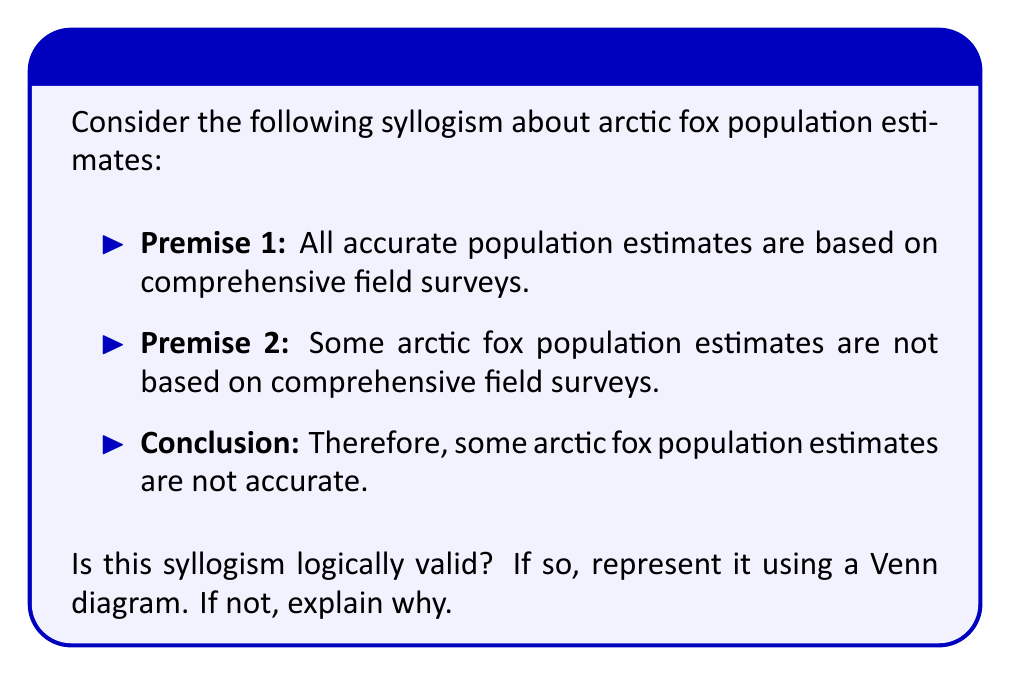Give your solution to this math problem. To determine the logical validity of this syllogism, let's follow these steps:

1. Identify the terms:
   A = accurate population estimates
   B = estimates based on comprehensive field surveys
   C = arctic fox population estimates

2. Translate the premises and conclusion into logical notation:
   Premise 1: All A are B → A ⊆ B
   Premise 2: Some C are not B → C ∩ B' ≠ ∅
   Conclusion: Some C are not A → C ∩ A' ≠ ∅

3. Analyze the logical structure:
   This syllogism follows the form of AOO-2, which is a valid syllogistic form.

4. Represent the syllogism using a Venn diagram:

[asy]
unitsize(1cm);

pair A = (0,0), B = (1,0), C = (0.5,0.866);
real r = 1;

draw(circle(A,r), blue);
draw(circle(B,r), red);
draw(circle(C,r), green);

label("A", A, SW);
label("B", B, SE);
label("C", C, N);

fill((-0.5,-0.866)--(0.5,-0.866)--(0,0)--cycle, blue+opacity(0.2));
fill((1.5,-0.866)--(0.5,-0.866)--(1,0)--cycle, red+opacity(0.2));

draw((0.5,-0.866)--(1,0), dashed);
draw((-0.5,-0.866)--(0,0), dashed);

label("X", (0.75,-0.433), black);
[/asy]

5. Interpret the Venn diagram:
   - The blue circle represents A (accurate estimates)
   - The red circle represents B (comprehensive field surveys)
   - The green circle represents C (arctic fox population estimates)
   - The "X" in the region C ∩ B' (C but not B) represents "Some C are not B"
   - This "X" is also in the region C ∩ A' (C but not A), which represents "Some C are not A"

6. Conclusion:
   The syllogism is logically valid because the Venn diagram demonstrates that if some arctic fox population estimates are not based on comprehensive field surveys (premise 2), and all accurate estimates are based on comprehensive field surveys (premise 1), then it necessarily follows that some arctic fox population estimates are not accurate (conclusion).
Answer: Valid 